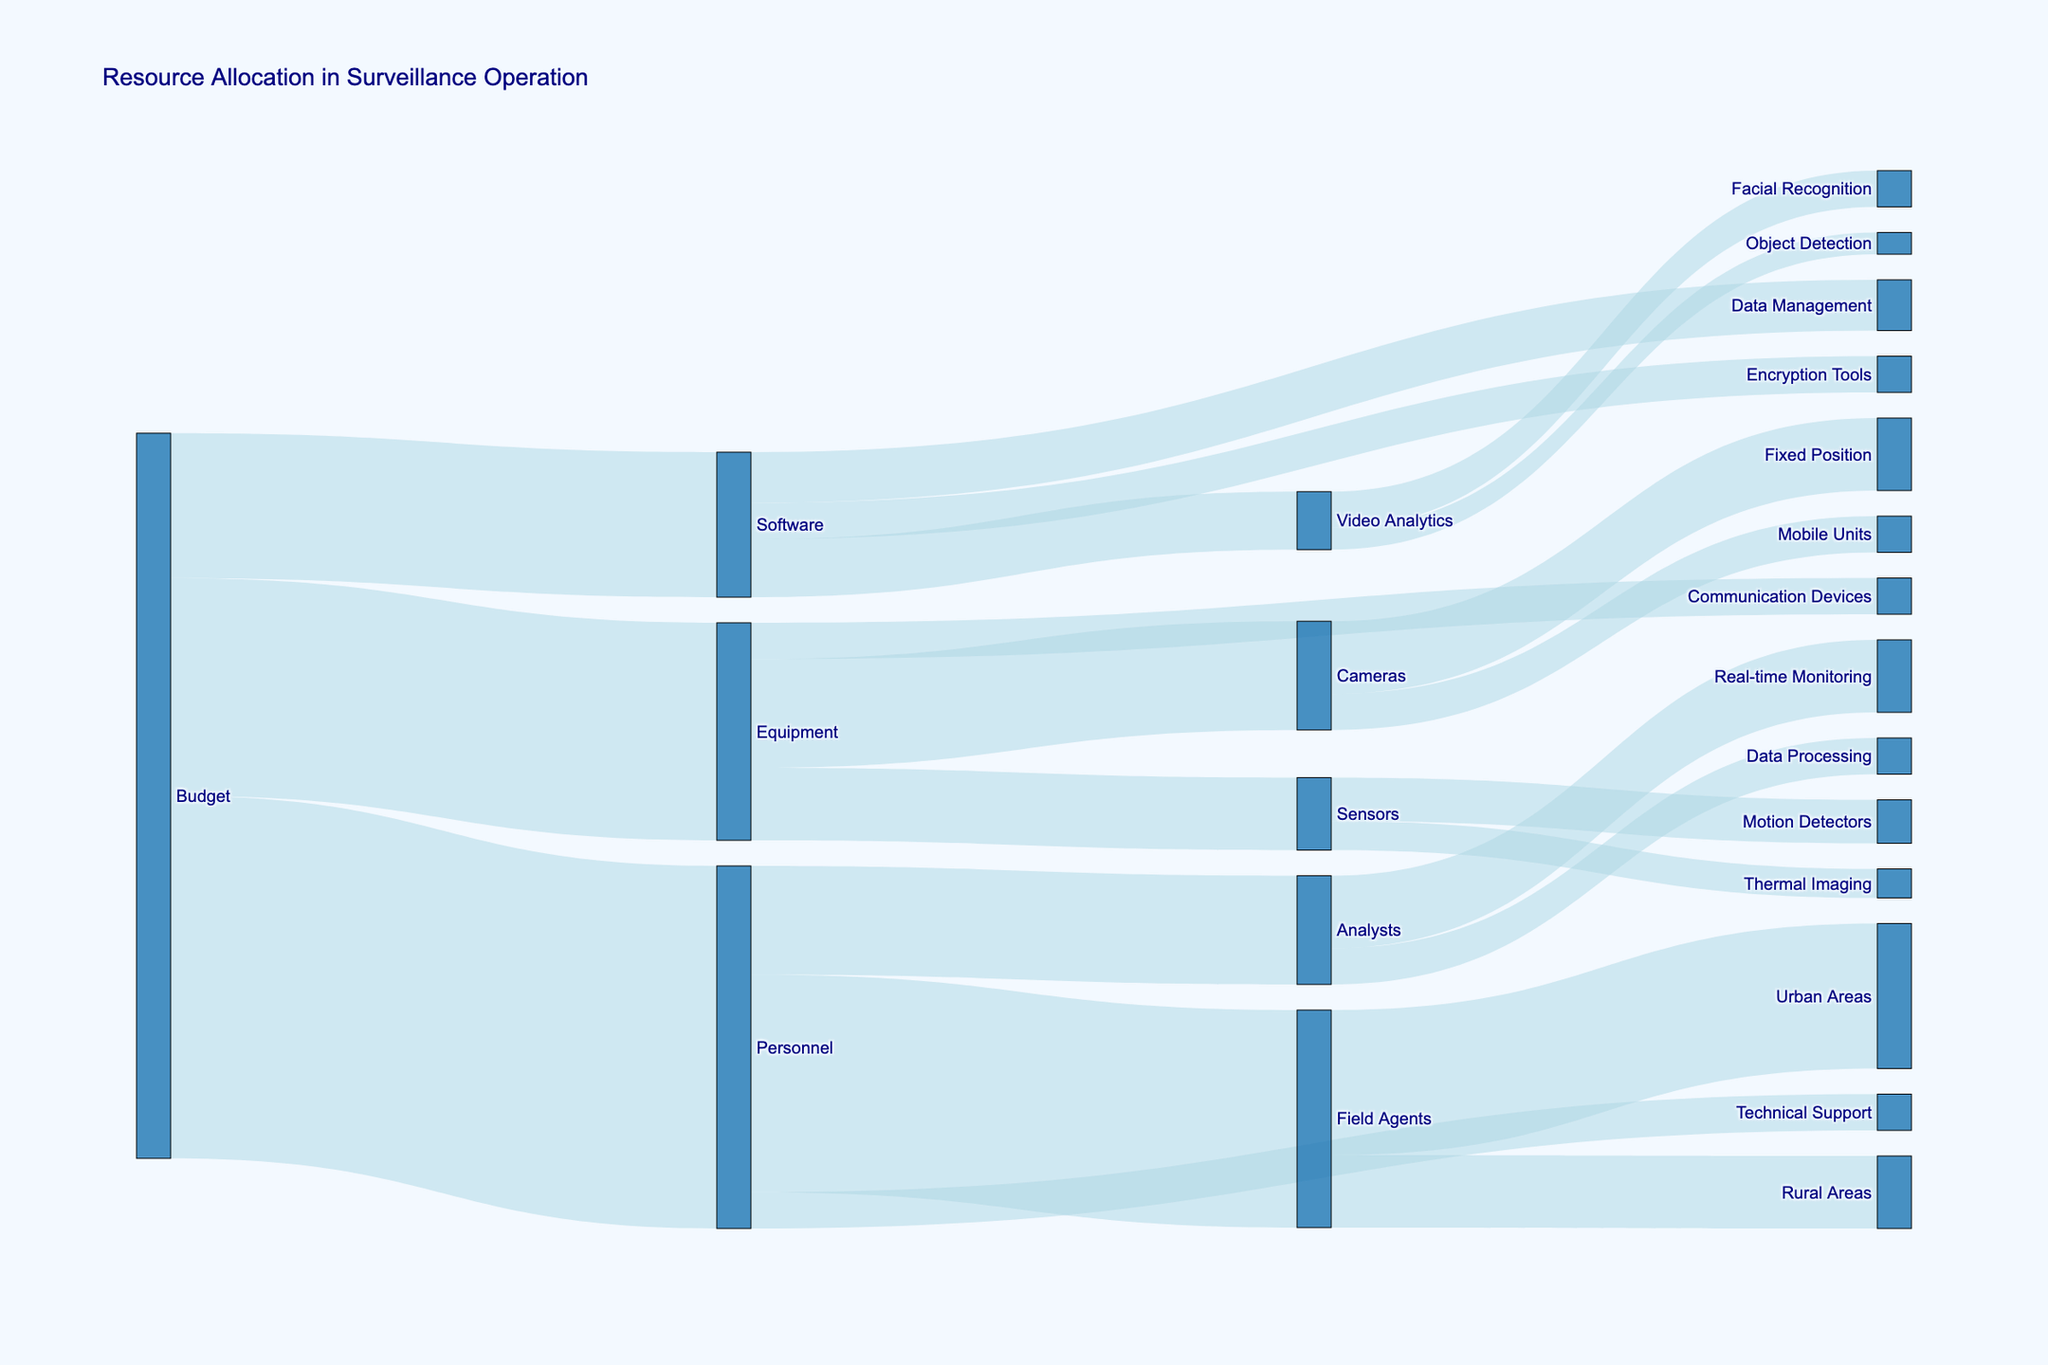what is the total budget allocated? To find the total budget, we consider the allocations to Personnel, Equipment, and Software, which sum up to 5000000 + 3000000 + 2000000.
Answer: 10000000 How much of the budget is allocated to Equipment? The figure shows a direct allocation from Budget to Equipment, which is labeled with the value.
Answer: 3000000 Which category under Equipment receives the most funding? Under Equipment, Cameras receive the most funding, with 1500000, compared to Sensors (1000000) and Communication Devices (500000).
Answer: Cameras Compare the funding received by Field Agents and Analysts. The figure shows Field Agents with a funding of 3000000 and Analysts with 1500000. Therefore, Field Agents have more funding.
Answer: Field Agents receive more funding What percentage of the Personnel budget is allocated to Field Agents? The Personnel budget is 5000000, and Field Agents receive 3000000. The percentage is (3000000/5000000) * 100.
Answer: 60% How is the Software budget distributed? The Software budget is distributed to Video Analytics (800000), Data Management (700000), and Encryption Tools (500000).
Answer: Video Analytics 800000, Data Management 700000, Encryption Tools 500000 What is the total allocation for urban areas? The allocation for urban areas comes from Field Agents, totaling 2000000.
Answer: 2000000 Compare the allocation for Motion Detectors and Thermal Imaging under Sensors. Motion Detectors receive 600000, while Thermal Imaging receives 400000, making Motion Detectors more funded.
Answer: Motion Detectors receive more funding Calculate the total allocation for both Real-time Monitoring and Data Processing under Analysts. Real-time Monitoring receives 1000000, and Data Processing gets 500000, giving a total of 1000000 + 500000.
Answer: 1500000 Is Facial Recognition funded more than Object Detection under Video Analytics? Facial Recognition receives 500000, while Object Detection gets 300000, so Facial Recognition is funded more.
Answer: Yes 